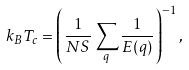<formula> <loc_0><loc_0><loc_500><loc_500>k _ { B } T _ { c } = \left ( \frac { 1 } { N S } \sum _ { q } \frac { 1 } { E ( { q } ) } \right ) ^ { - 1 } ,</formula> 